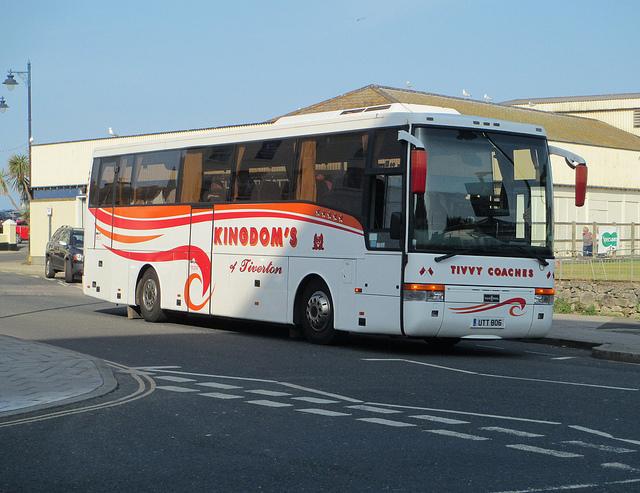What color is building behind bus?
Answer briefly. White. Is the bus door open?
Concise answer only. No. What color are the lettering on the bus?
Keep it brief. Red. What bus company is it?
Write a very short answer. Tivvy. 